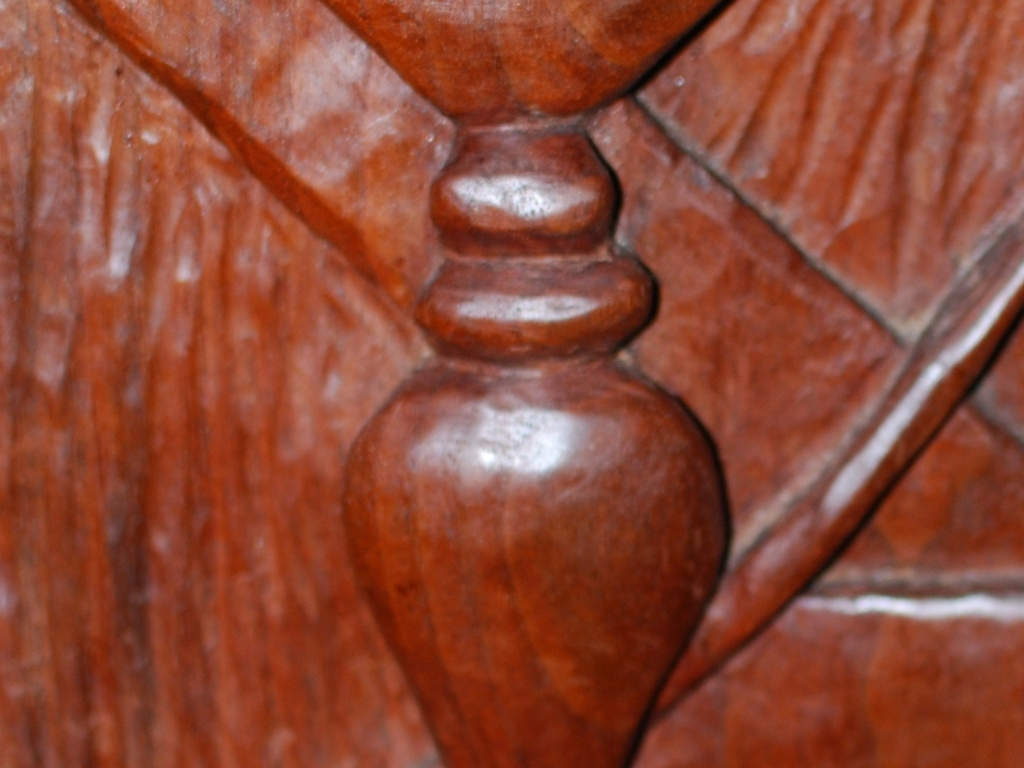What might be the function of this object, based on its design? The design elements suggest that this could be a structural detail of a piece of wooden furniture, such as the leg of a table or chair, displaying a classic turning artwork common in woodworking. 